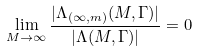Convert formula to latex. <formula><loc_0><loc_0><loc_500><loc_500>\lim _ { M \to \infty } \frac { | \Lambda _ { ( \infty , m ) } ( M , \Gamma ) | } { | \Lambda ( M , \Gamma ) | } = 0</formula> 